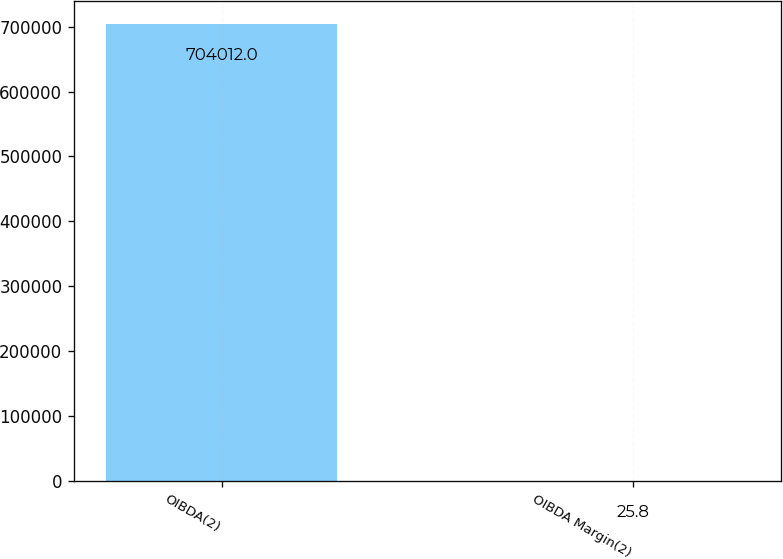Convert chart. <chart><loc_0><loc_0><loc_500><loc_500><bar_chart><fcel>OIBDA(2)<fcel>OIBDA Margin(2)<nl><fcel>704012<fcel>25.8<nl></chart> 